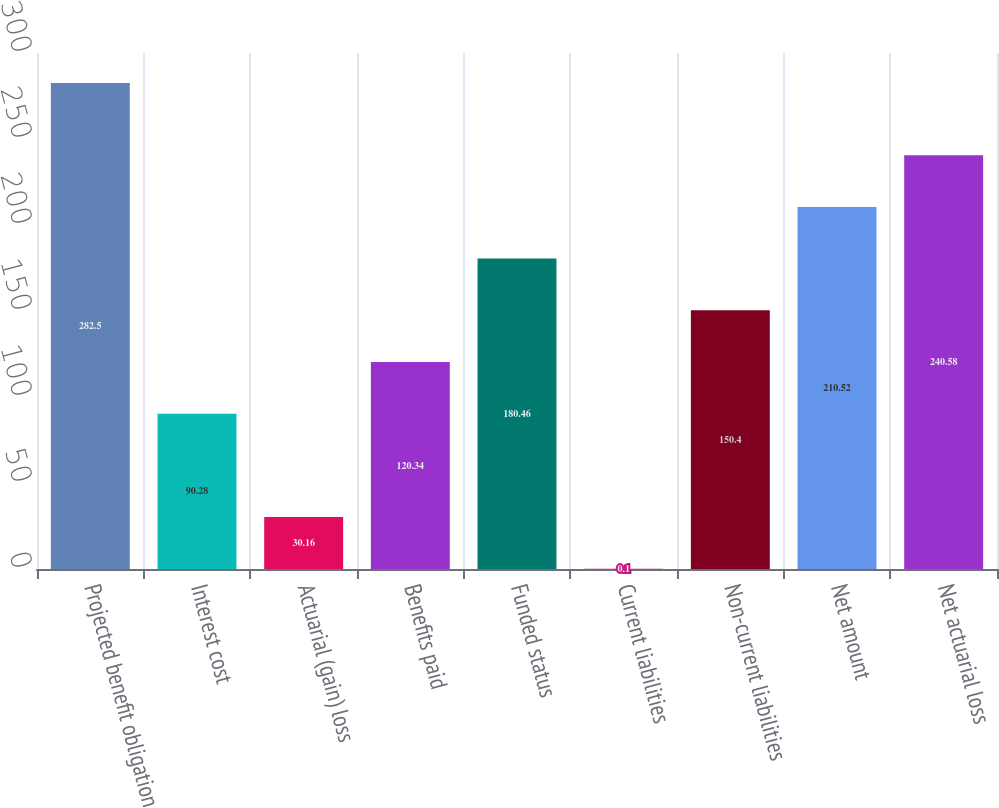<chart> <loc_0><loc_0><loc_500><loc_500><bar_chart><fcel>Projected benefit obligation<fcel>Interest cost<fcel>Actuarial (gain) loss<fcel>Benefits paid<fcel>Funded status<fcel>Current liabilities<fcel>Non-current liabilities<fcel>Net amount<fcel>Net actuarial loss<nl><fcel>282.5<fcel>90.28<fcel>30.16<fcel>120.34<fcel>180.46<fcel>0.1<fcel>150.4<fcel>210.52<fcel>240.58<nl></chart> 